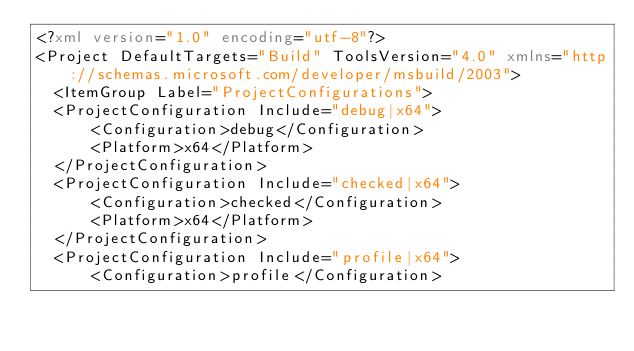Convert code to text. <code><loc_0><loc_0><loc_500><loc_500><_XML_><?xml version="1.0" encoding="utf-8"?>
<Project DefaultTargets="Build" ToolsVersion="4.0" xmlns="http://schemas.microsoft.com/developer/msbuild/2003">
	<ItemGroup Label="ProjectConfigurations">
	<ProjectConfiguration Include="debug|x64">
			<Configuration>debug</Configuration>
			<Platform>x64</Platform>
	</ProjectConfiguration>
	<ProjectConfiguration Include="checked|x64">
			<Configuration>checked</Configuration>
			<Platform>x64</Platform>
	</ProjectConfiguration>
	<ProjectConfiguration Include="profile|x64">
			<Configuration>profile</Configuration></code> 